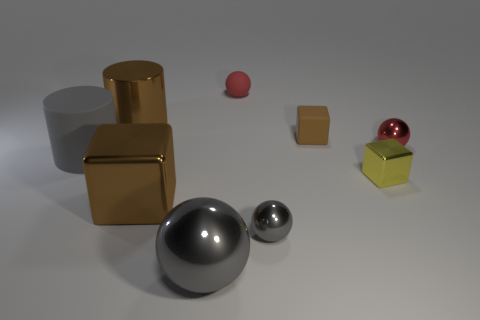Subtract all tiny cubes. How many cubes are left? 1 Subtract 2 spheres. How many spheres are left? 2 Add 1 small cyan metal cylinders. How many objects exist? 10 Subtract all green spheres. Subtract all green cubes. How many spheres are left? 4 Subtract all cylinders. How many objects are left? 7 Add 6 small yellow blocks. How many small yellow blocks exist? 7 Subtract 0 purple cubes. How many objects are left? 9 Subtract all tiny blue shiny things. Subtract all tiny brown matte cubes. How many objects are left? 8 Add 1 small brown matte objects. How many small brown matte objects are left? 2 